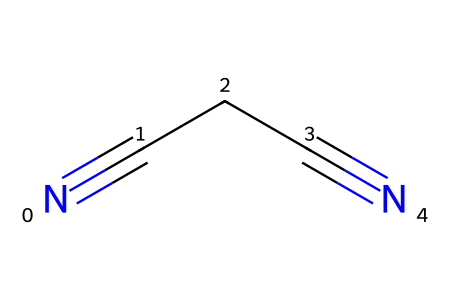What is the name of the chemical represented by the SMILES N#CCC#N? The SMILES notation presents a compound with two cyanide (nitrile) groups at both ends and a three-carbon chain in between, which is called malononitrile.
Answer: malononitrile How many carbon atoms are present in malononitrile? By analyzing the SMILES structure, we see that there are three carbon atoms depicted in the linear arrangement between the two nitrogen atoms connected through triple bonds.
Answer: 3 What type of hybridization do the carbon atoms in malononitrile have? Each carbon in the chain is trigonal planar due to the formation of sp2 hybridization, which is typically associated with carbon atoms in nitriles connected to a triple bond.
Answer: sp2 What functional groups are present in malononitrile? The structure contains two nitrile functional groups (-C≡N), which are indicated by the triple bonds to nitrogen at both terminal positions of the carbon chain.
Answer: nitrile Why is malononitrile significant in pharmaceutical synthesis? Malononitrile serves as a versatile building block in pharmaceuticals, particularly in the synthesis of cognitive enhancers, due to its reactivity and the introduction of the nitrile functional groups which can affect biological activity.
Answer: cognitive enhancers What is the total number of nitrogen atoms in malononitrile? From the SMILES representation, we can see that two nitrogen atoms are present at each end of the molecule connected to the carbon atoms.
Answer: 2 